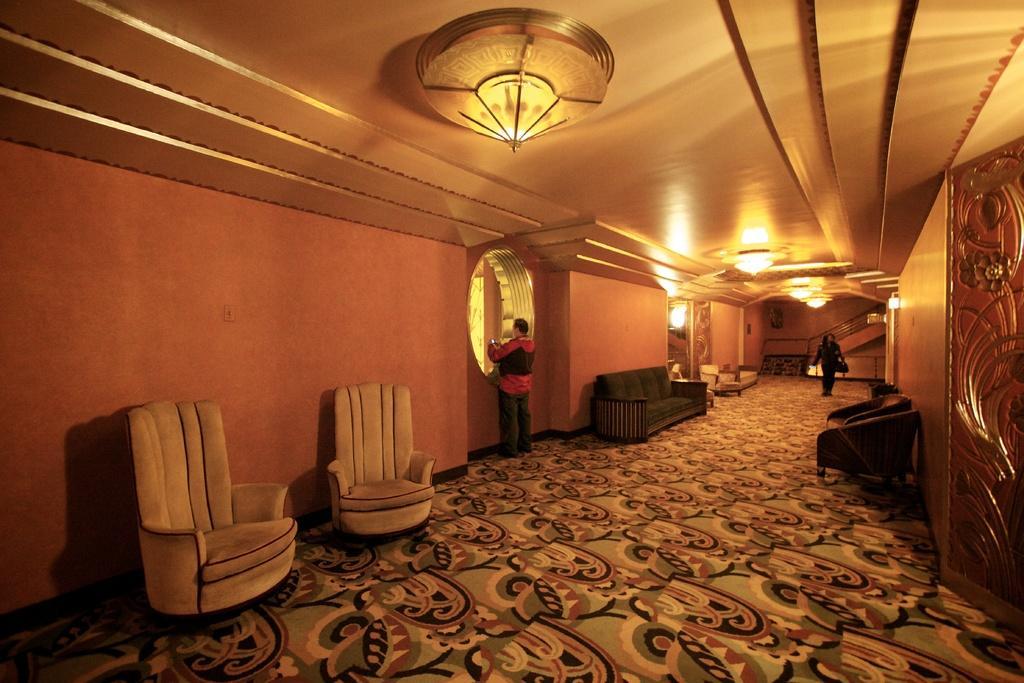Describe this image in one or two sentences. This Image is clicked inside. There is a sofa and chairs in this image. There are stairs in this image. There are lights on the top. There are two persons who are standing. 